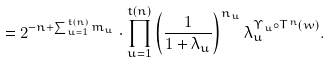Convert formula to latex. <formula><loc_0><loc_0><loc_500><loc_500>= 2 ^ { - n + \sum _ { u = 1 } ^ { t ( n ) } m _ { u } } \cdot \prod _ { u = 1 } ^ { t ( n ) } \left ( \frac { 1 } { 1 + \lambda _ { u } } \right ) ^ { n _ { u } } \lambda _ { u } ^ { \Upsilon _ { u } \circ T ^ { n } \left ( w \right ) } .</formula> 